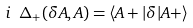Convert formula to latex. <formula><loc_0><loc_0><loc_500><loc_500>i \ \Delta _ { + } ( \delta A , A ) = \langle A + | \delta | A + \rangle</formula> 